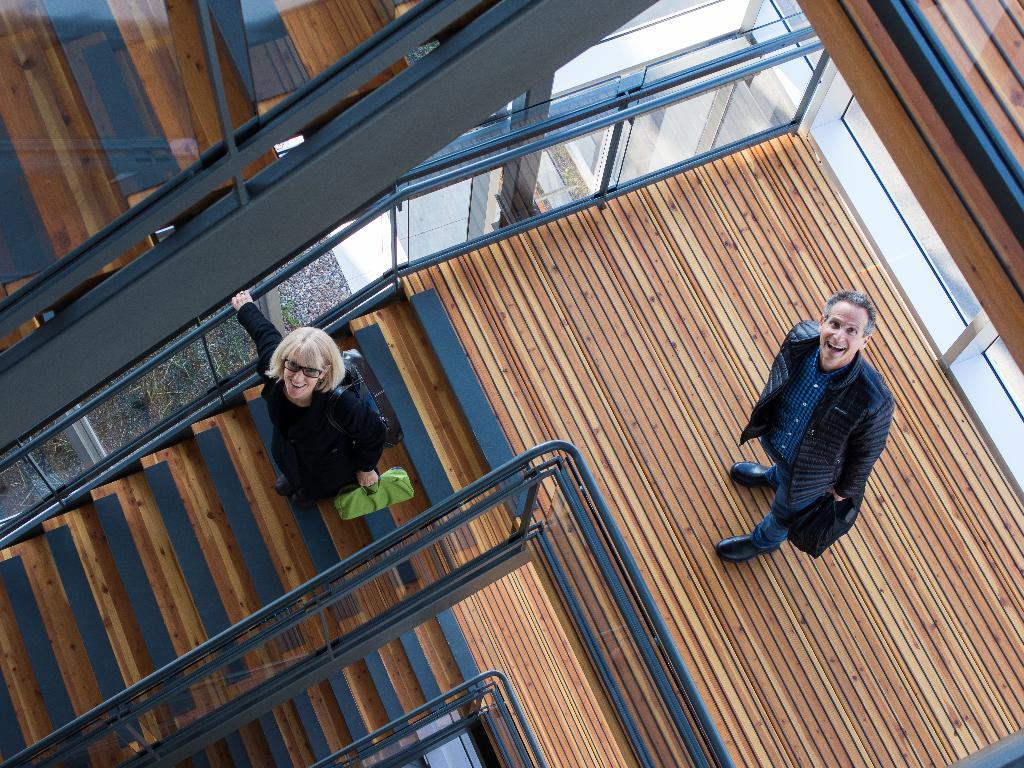What type of structure is present in the image? There are stairs in the image. How many floors have stairs? The stairs are on every floor. What is happening on one of the floors? On one of the floors, there are two persons standing. What is one of the persons holding? One of the persons is holding a bag in her hand. What type of plough is being used by the person on the stairs? There is no plough present in the image; it features stairs and people standing on one of the floors. How does the person on the stairs manage to control their temper? There is no indication of the person's temper in the image, as it only shows stairs and people standing on one of the floors. 